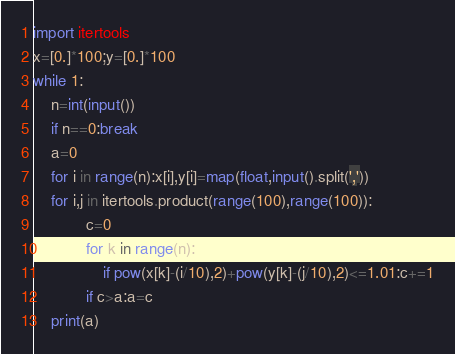Convert code to text. <code><loc_0><loc_0><loc_500><loc_500><_Python_>import itertools
x=[0.]*100;y=[0.]*100
while 1:
    n=int(input())
    if n==0:break
    a=0
    for i in range(n):x[i],y[i]=map(float,input().split(','))
    for i,j in itertools.product(range(100),range(100)):
            c=0
            for k in range(n):
                if pow(x[k]-(i/10),2)+pow(y[k]-(j/10),2)<=1.01:c+=1
            if c>a:a=c
    print(a)</code> 